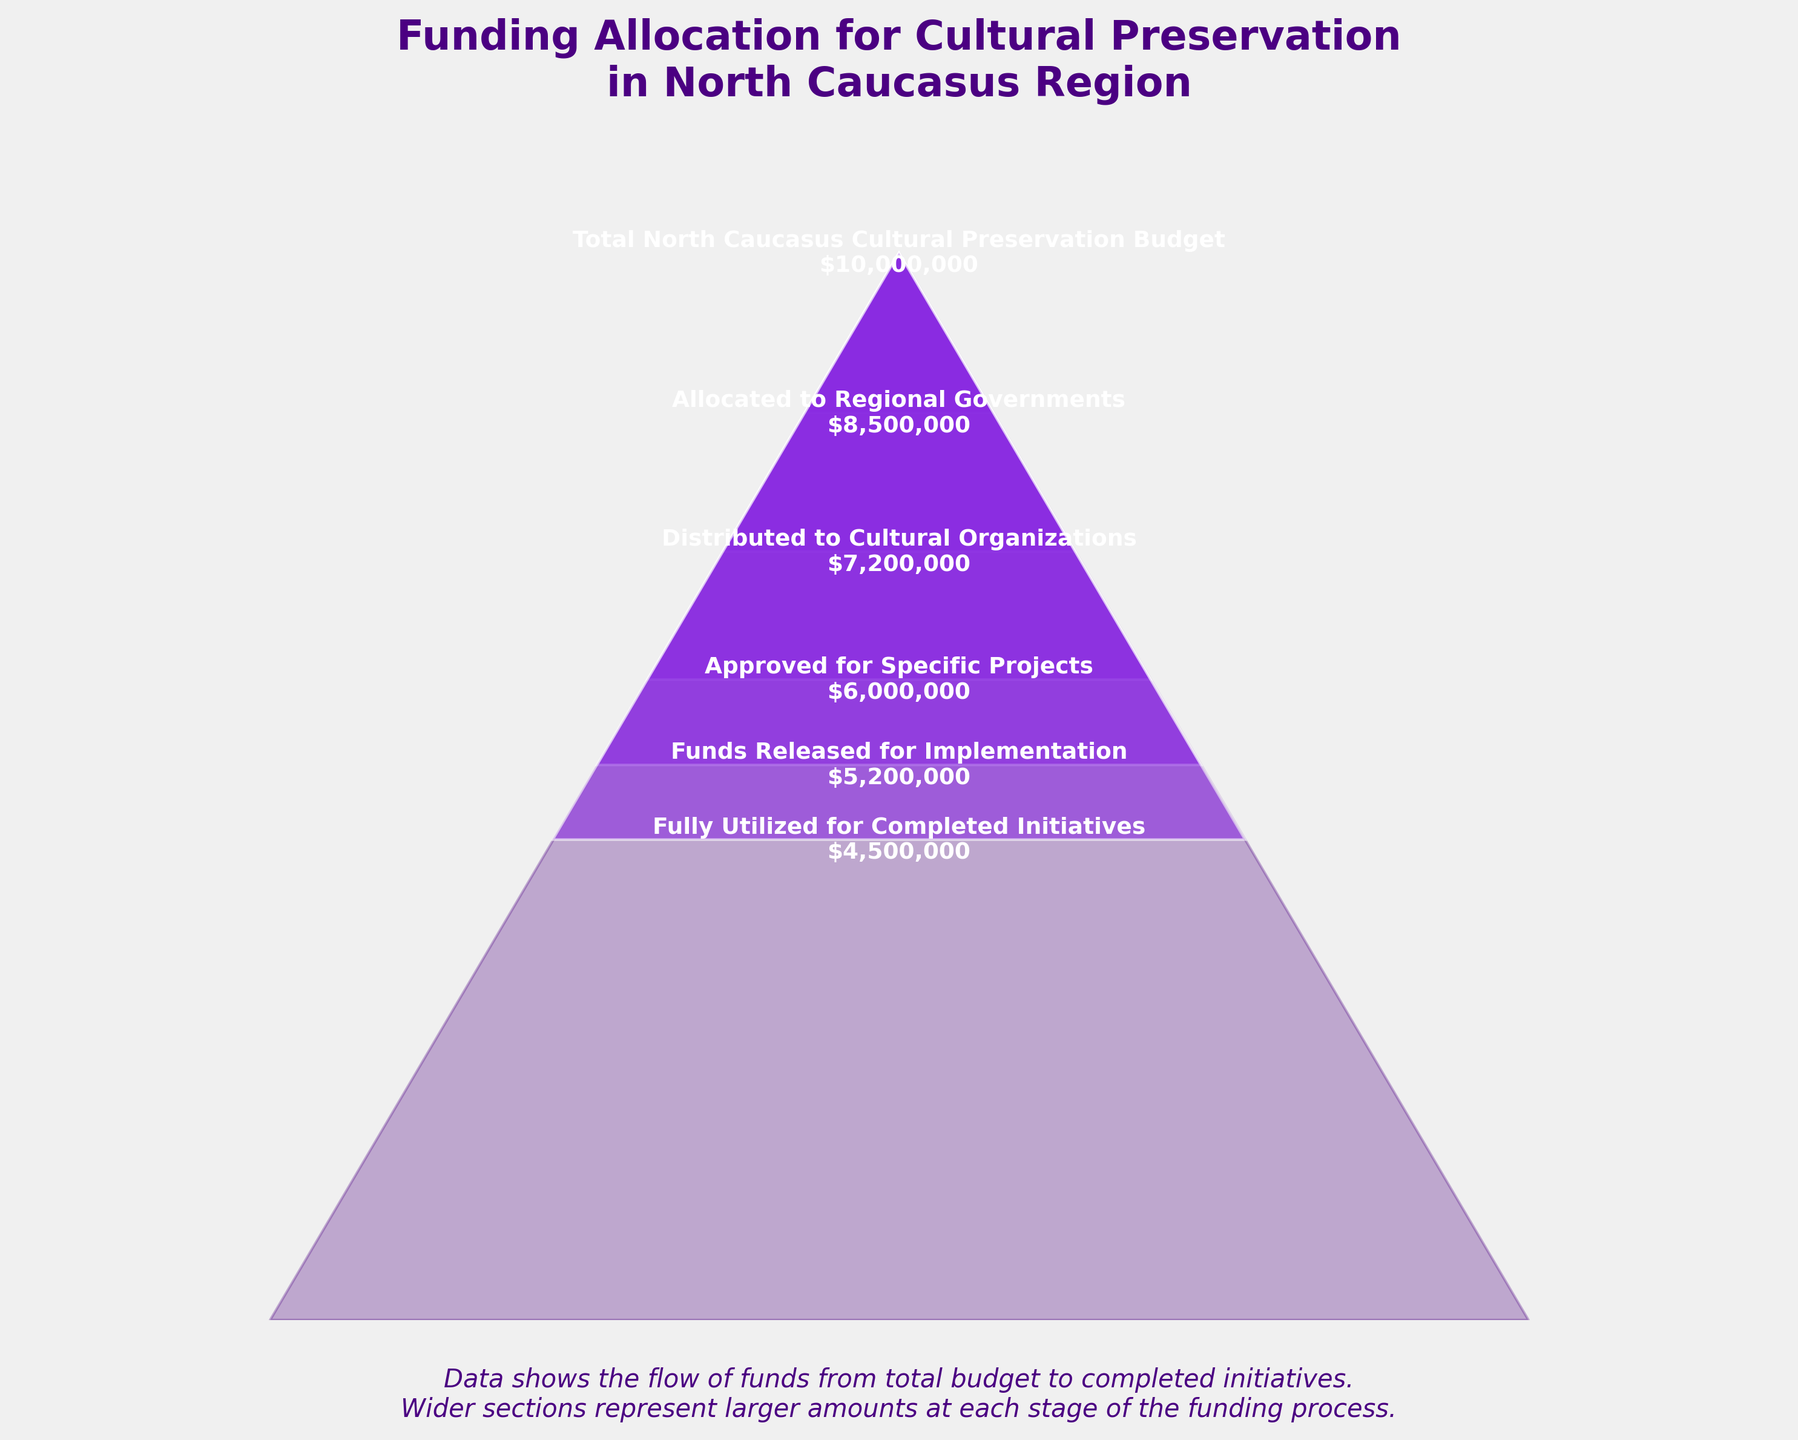What is the total budget for cultural preservation in the North Caucasus region? To find the total budget, look at the topmost stage in the funnel chart labeled "Total North Caucasus Cultural Preservation Budget" with the corresponding funding amount.
Answer: $10,000,000 How much funding is allocated to regional governments? To determine the amount allocated to regional governments, look at the second stage from the top of the funnel chart labeled "Allocated to Regional Governments."
Answer: $8,500,000 At which stage does the funding reach $6,000,000? Identify the stage that corresponds to the funding amount of $6,000,000 by checking labels of the stages. This amount is found under "Approved for Specific Projects."
Answer: Approved for Specific Projects How much less funding is released for implementation than the total budget? First, note the total budget ($10,000,000) and the funds released for implementation ($5,200,000), then calculate the difference by subtracting the latter from the former: $10,000,000 - $5,200,000 = $4,800,000.
Answer: $4,800,000 Which stage has the smallest amount of funding? Look at the funnel chart and identify the stage with the lowest funding amount. The last stage, "Fully Utilized for Completed Initiatives," has the smallest amount.
Answer: $4,500,000 Is the amount allocated to regional governments more or less than the amount distributed to cultural organizations? Compare the amounts for both stages: $8,500,000 (Allocated to Regional Governments) and $7,200,000 (Distributed to Cultural Organizations). Since $8,500,000 is greater than $7,200,000, it is more.
Answer: More How much funding is left for specific projects after distribution to cultural organizations? Calculate the difference between the distributed amount ($7,200,000) and the approved amount for specific projects ($6,000,000): $7,200,000 - $6,000,000 = $1,200,000.
Answer: $1,200,000 What is the difference in funding between the approved projects and fully utilized initiatives? Subtract the amount for fully utilized initiatives ($4,500,000) from the approved amount for specific projects ($6,000,000): $6,000,000 - $4,500,000 = $1,500,000.
Answer: $1,500,000 In which stage does the funnel chart show the highest allocation of funds? The widest section of the funnel chart represents the stage with the highest allocation, which is the "Total North Caucasus Cultural Preservation Budget" stage.
Answer: Total North Caucasus Cultural Preservation Budget 